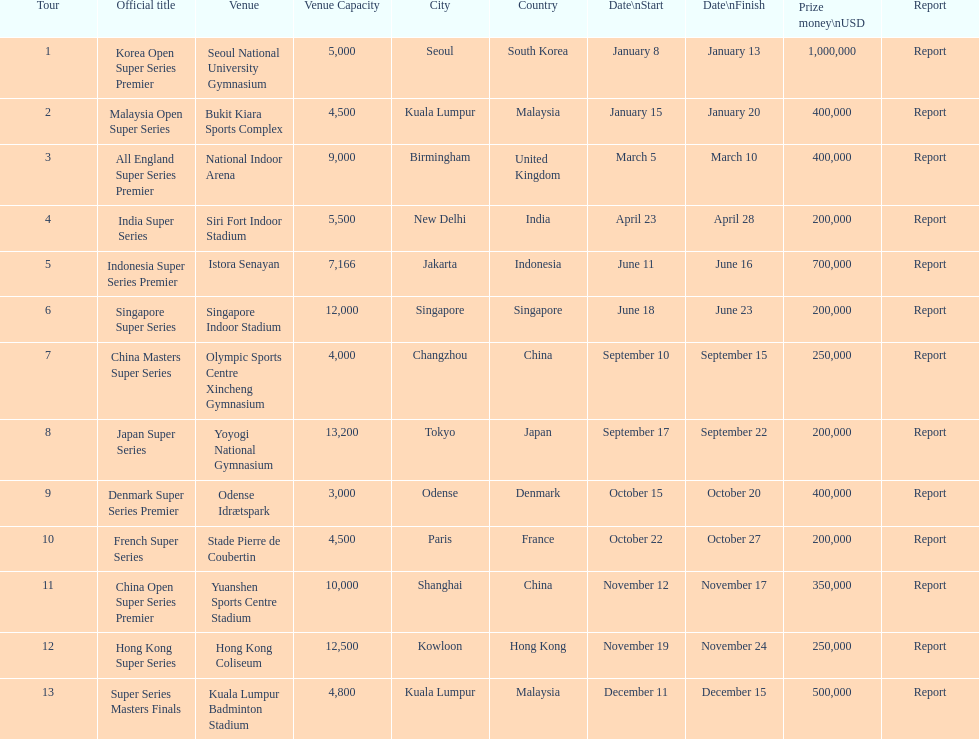In which series is the top prize amount the highest? Korea Open Super Series Premier. 